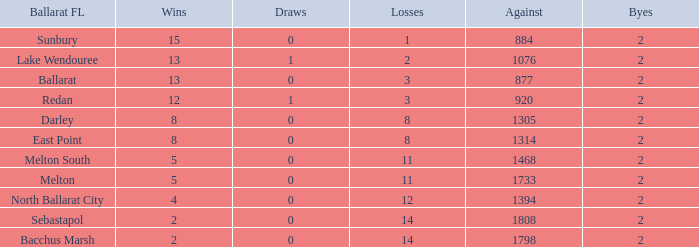What is the number of instances where darley has faced opposition in the ballarat fl and achieved over 8 victories? 0.0. 